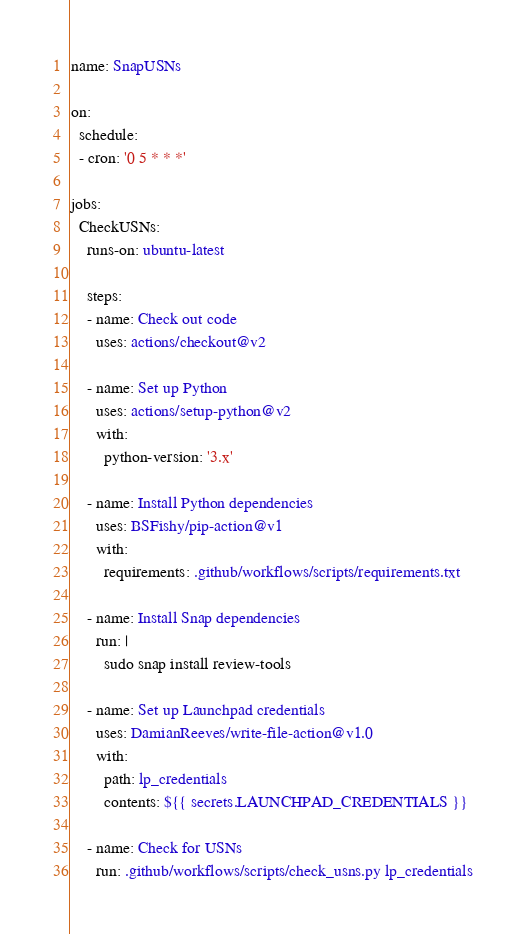Convert code to text. <code><loc_0><loc_0><loc_500><loc_500><_YAML_>name: SnapUSNs

on:
  schedule:
  - cron: '0 5 * * *'

jobs:
  CheckUSNs:
    runs-on: ubuntu-latest

    steps:
    - name: Check out code
      uses: actions/checkout@v2

    - name: Set up Python
      uses: actions/setup-python@v2
      with:
        python-version: '3.x'

    - name: Install Python dependencies
      uses: BSFishy/pip-action@v1
      with:
        requirements: .github/workflows/scripts/requirements.txt

    - name: Install Snap dependencies
      run: |
        sudo snap install review-tools

    - name: Set up Launchpad credentials
      uses: DamianReeves/write-file-action@v1.0
      with:
        path: lp_credentials
        contents: ${{ secrets.LAUNCHPAD_CREDENTIALS }}

    - name: Check for USNs
      run: .github/workflows/scripts/check_usns.py lp_credentials
</code> 